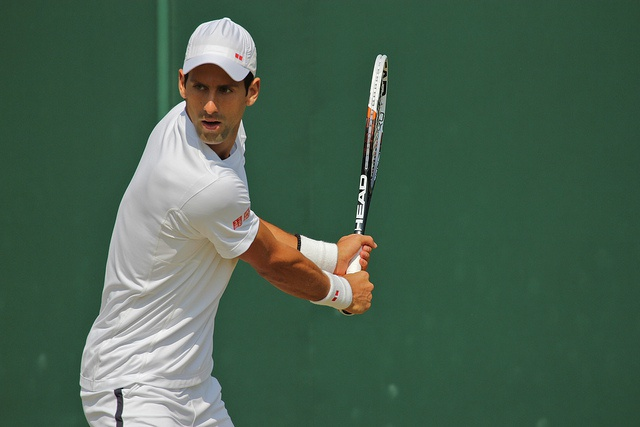Describe the objects in this image and their specific colors. I can see people in darkgreen, darkgray, lightgray, maroon, and gray tones and tennis racket in darkgreen, black, lightgray, and darkgray tones in this image. 